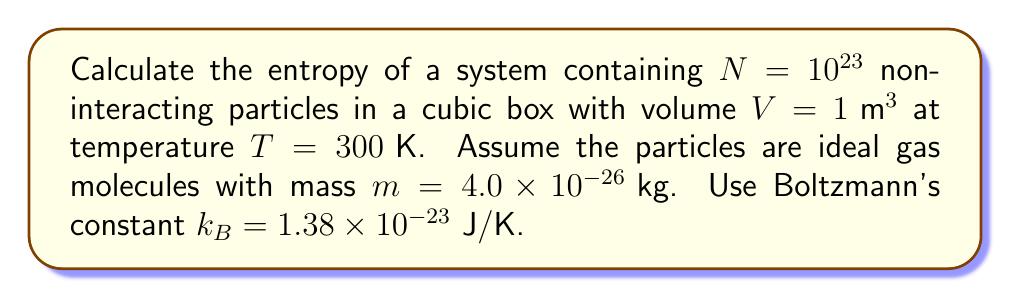Give your solution to this math problem. Let's approach this step-by-step using the Sackur-Tetrode equation for the entropy of an ideal gas:

1) The Sackur-Tetrode equation is:

   $$S = Nk_B \left[\ln\left(\frac{V}{N}\left(\frac{4\pi mUe}{3Nh^2}\right)^{3/2}\right) + \frac{5}{2}\right]$$

   where $U$ is the internal energy, $h$ is Planck's constant, and $e$ is Euler's number.

2) For an ideal gas, $U = \frac{3}{2}Nk_BT$

3) Substituting the values:
   $N = 10^{23}$
   $V = 1\text{ m}^3$
   $m = 4.0 \times 10^{-26}\text{ kg}$
   $T = 300\text{ K}$
   $k_B = 1.38 \times 10^{-23}\text{ J/K}$
   $h = 6.626 \times 10^{-34}\text{ J⋅s}$
   $e = 2.718$

4) First, calculate $U$:
   $$U = \frac{3}{2} \times 10^{23} \times 1.38 \times 10^{-23} \times 300 = 6.21 \times 10^3\text{ J}$$

5) Now, let's substitute all values into the Sackur-Tetrode equation:

   $$S = 10^{23} \times 1.38 \times 10^{-23} \left[\ln\left(\frac{1}{10^{23}}\left(\frac{4\pi \times 4.0 \times 10^{-26} \times 6.21 \times 10^3 \times 2.718}{3 \times 10^{23} \times (6.626 \times 10^{-34})^2}\right)^{3/2}\right) + \frac{5}{2}\right]$$

6) Simplify the expression inside the logarithm:

   $$S = 1.38 \times 10^{-23} \times 10^{23} \left[\ln\left(1.60 \times 10^{-22} \times (1.09 \times 10^{32})^{3/2}\right) + \frac{5}{2}\right]$$

7) Calculate:

   $$S = 1.38 \left[\ln(5.70 \times 10^{26}) + \frac{5}{2}\right] = 1.38 [61.75 + 2.5] = 88.65\text{ J/K}$$
Answer: $88.65\text{ J/K}$ 